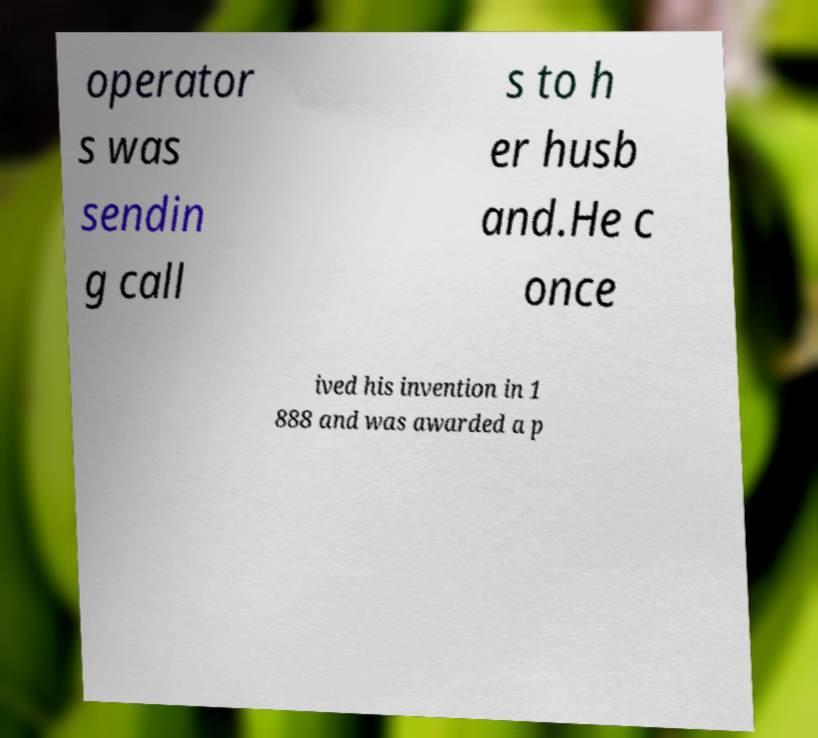Could you assist in decoding the text presented in this image and type it out clearly? operator s was sendin g call s to h er husb and.He c once ived his invention in 1 888 and was awarded a p 